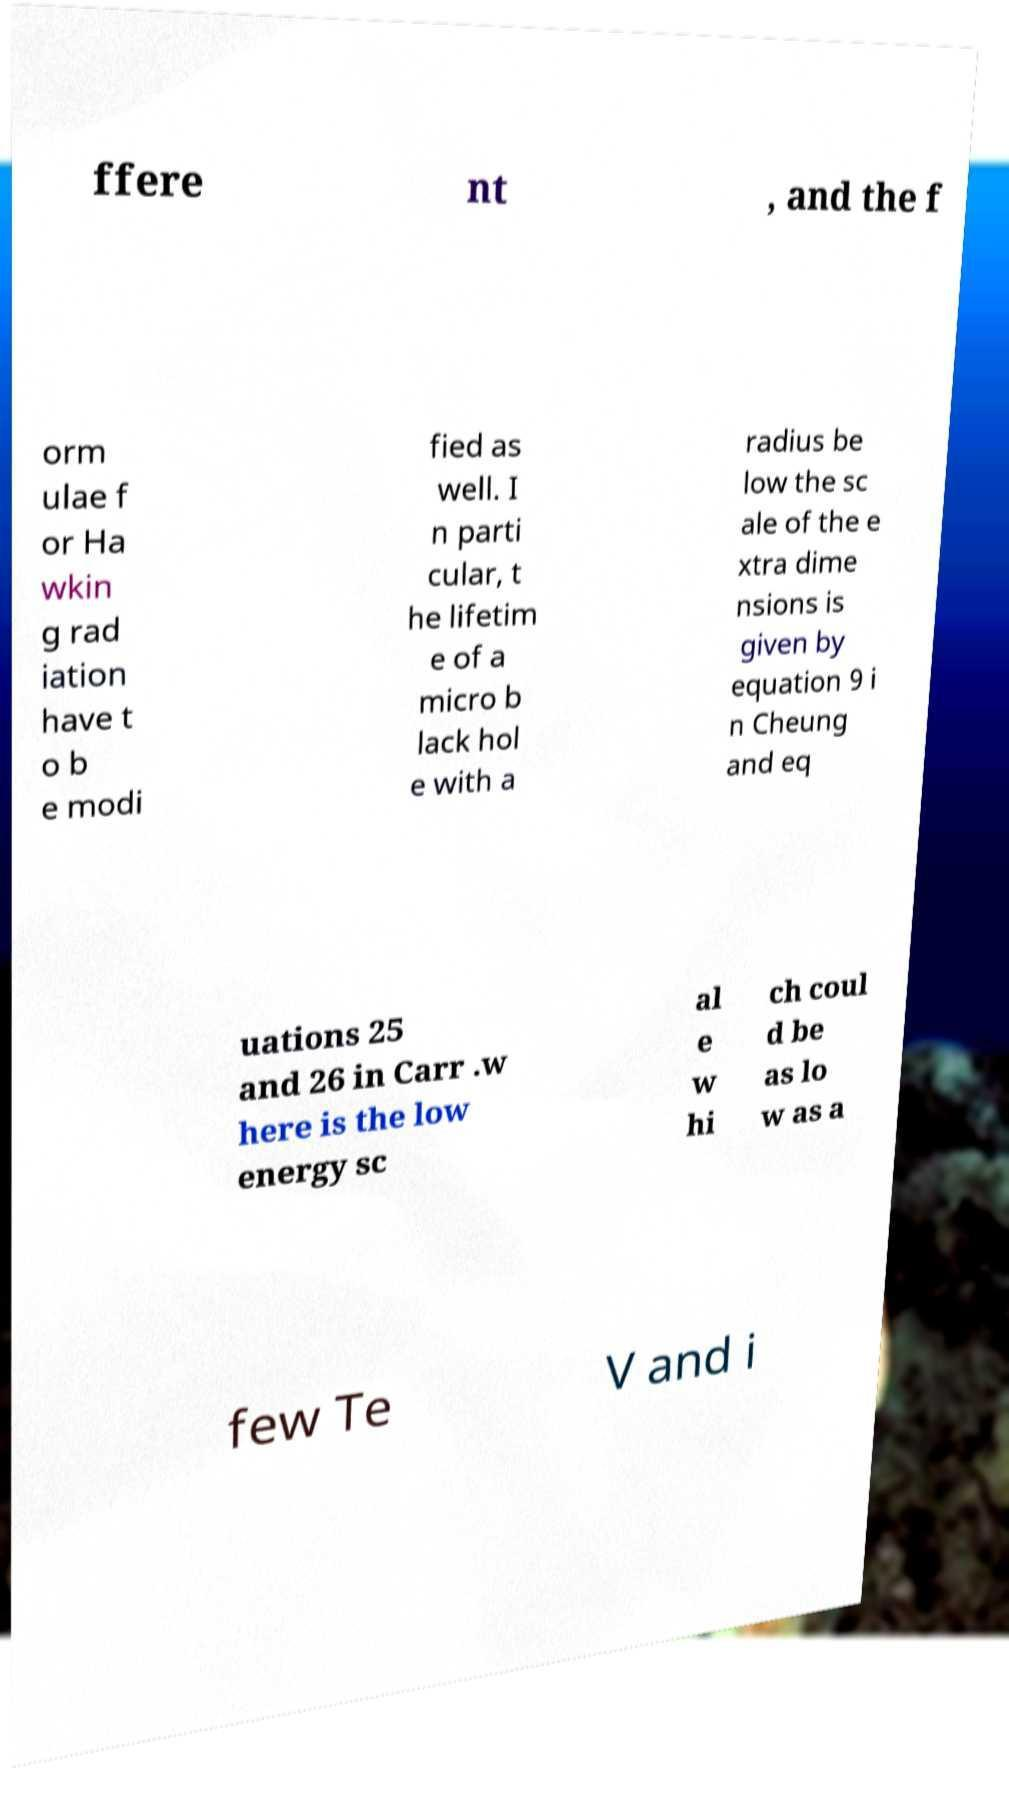Could you assist in decoding the text presented in this image and type it out clearly? ffere nt , and the f orm ulae f or Ha wkin g rad iation have t o b e modi fied as well. I n parti cular, t he lifetim e of a micro b lack hol e with a radius be low the sc ale of the e xtra dime nsions is given by equation 9 i n Cheung and eq uations 25 and 26 in Carr .w here is the low energy sc al e w hi ch coul d be as lo w as a few Te V and i 